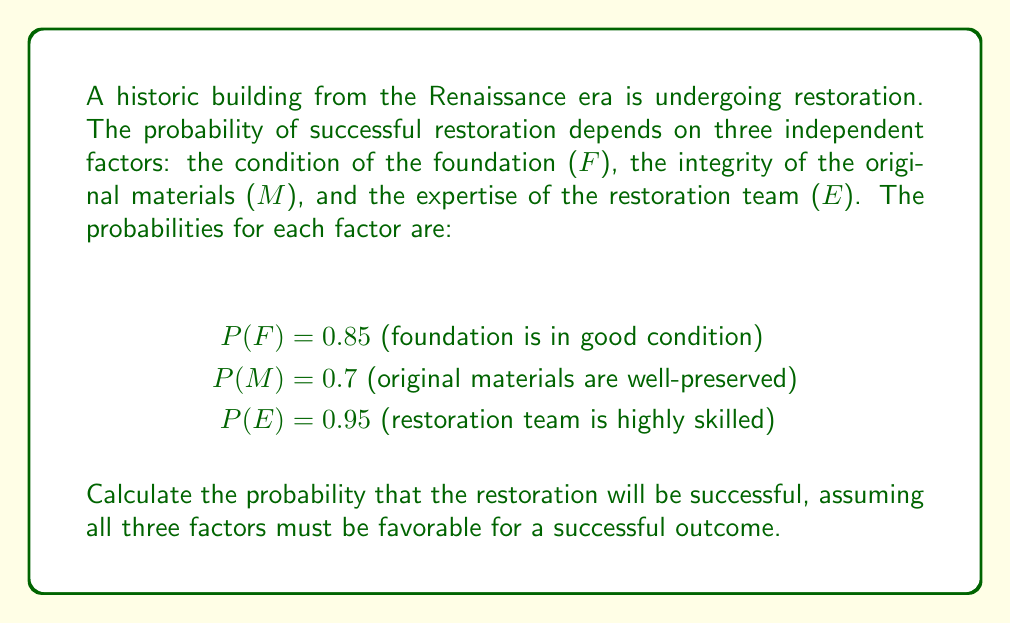Give your solution to this math problem. To solve this problem, we need to use the multiplication rule for independent events. Since all three factors must be favorable for a successful restoration, we need to calculate the probability of all three events occurring simultaneously.

Step 1: Identify the probabilities of each independent event:
$P(F) = 0.85$
$P(M) = 0.7$
$P(E) = 0.95$

Step 2: Apply the multiplication rule for independent events. The probability of all three events occurring is the product of their individual probabilities:

$$P(\text{Successful Restoration}) = P(F) \times P(M) \times P(E)$$

Step 3: Substitute the values and calculate:

$$P(\text{Successful Restoration}) = 0.85 \times 0.7 \times 0.95$$

Step 4: Multiply the numbers:

$$P(\text{Successful Restoration}) = 0.56525$$

Step 5: Round to four decimal places:

$$P(\text{Successful Restoration}) \approx 0.5653$$

Therefore, the probability of a successful restoration of the Renaissance-era building, given the conditions of the foundation, original materials, and restoration team expertise, is approximately 0.5653 or 56.53%.
Answer: 0.5653 